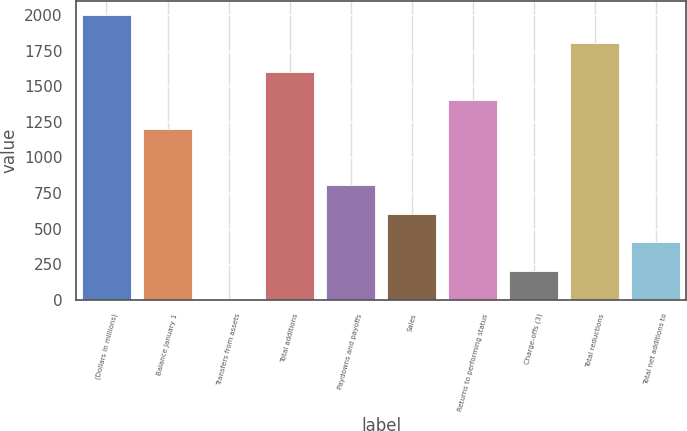Convert chart. <chart><loc_0><loc_0><loc_500><loc_500><bar_chart><fcel>(Dollars in millions)<fcel>Balance January 1<fcel>Transfers from assets<fcel>Total additions<fcel>Paydowns and payoffs<fcel>Sales<fcel>Returns to performing status<fcel>Charge-offs (3)<fcel>Total reductions<fcel>Total net additions to<nl><fcel>2003<fcel>1203.8<fcel>5<fcel>1603.4<fcel>804.2<fcel>604.4<fcel>1403.6<fcel>204.8<fcel>1803.2<fcel>404.6<nl></chart> 